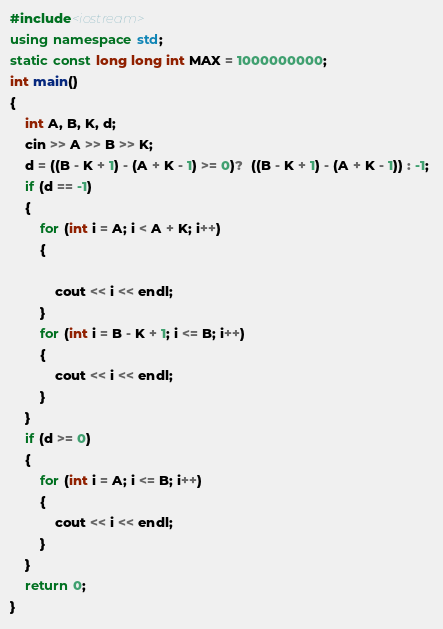Convert code to text. <code><loc_0><loc_0><loc_500><loc_500><_C++_>#include<iostream>
using namespace std;
static const long long int MAX = 1000000000; 
int main()
{
    int A, B, K, d;
    cin >> A >> B >> K;
    d = ((B - K + 1) - (A + K - 1) >= 0)?  ((B - K + 1) - (A + K - 1)) : -1; 
    if (d == -1)
    {
        for (int i = A; i < A + K; i++)
        {

            cout << i << endl;
        }
        for (int i = B - K + 1; i <= B; i++)
        {
            cout << i << endl;
        }
    }
    if (d >= 0)
    {
        for (int i = A; i <= B; i++)
        {
            cout << i << endl;
        }
    }
    return 0;
}</code> 